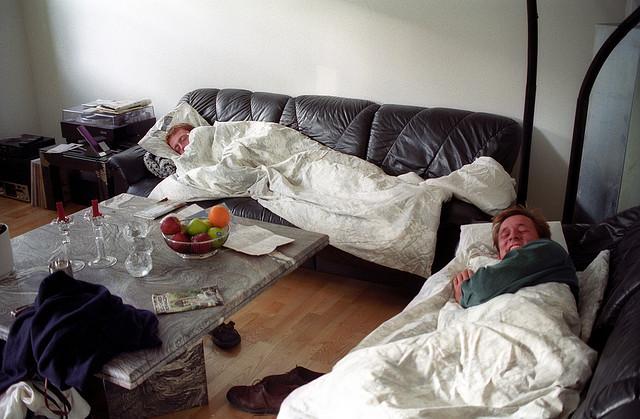Is one of the persons awake?
Be succinct. Yes. What is orange?
Write a very short answer. Orange. What are the couches made of?
Quick response, please. Leather. 